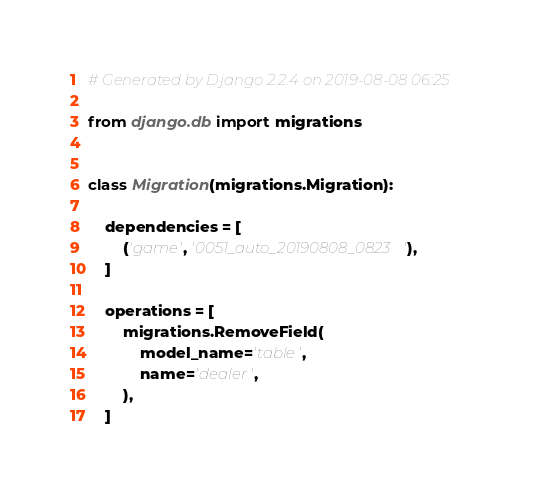Convert code to text. <code><loc_0><loc_0><loc_500><loc_500><_Python_># Generated by Django 2.2.4 on 2019-08-08 06:25

from django.db import migrations


class Migration(migrations.Migration):

    dependencies = [
        ('game', '0051_auto_20190808_0823'),
    ]

    operations = [
        migrations.RemoveField(
            model_name='table',
            name='dealer',
        ),
    ]
</code> 